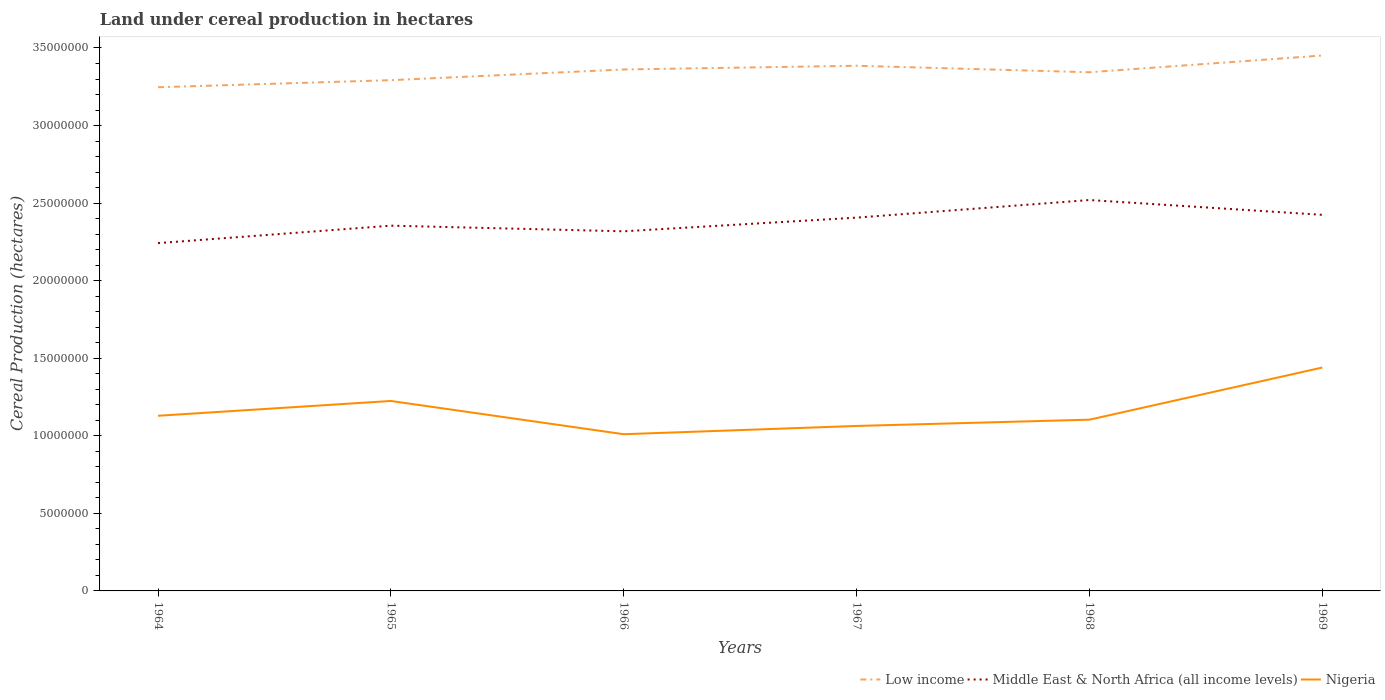Does the line corresponding to Middle East & North Africa (all income levels) intersect with the line corresponding to Low income?
Keep it short and to the point. No. Across all years, what is the maximum land under cereal production in Middle East & North Africa (all income levels)?
Keep it short and to the point. 2.24e+07. In which year was the land under cereal production in Nigeria maximum?
Provide a succinct answer. 1966. What is the total land under cereal production in Middle East & North Africa (all income levels) in the graph?
Your response must be concise. -8.82e+05. What is the difference between the highest and the second highest land under cereal production in Low income?
Your response must be concise. 2.05e+06. Is the land under cereal production in Nigeria strictly greater than the land under cereal production in Middle East & North Africa (all income levels) over the years?
Provide a short and direct response. Yes. Are the values on the major ticks of Y-axis written in scientific E-notation?
Your answer should be very brief. No. Does the graph contain grids?
Make the answer very short. No. Where does the legend appear in the graph?
Offer a very short reply. Bottom right. How many legend labels are there?
Provide a succinct answer. 3. How are the legend labels stacked?
Keep it short and to the point. Horizontal. What is the title of the graph?
Keep it short and to the point. Land under cereal production in hectares. What is the label or title of the Y-axis?
Offer a terse response. Cereal Production (hectares). What is the Cereal Production (hectares) of Low income in 1964?
Provide a short and direct response. 3.25e+07. What is the Cereal Production (hectares) of Middle East & North Africa (all income levels) in 1964?
Give a very brief answer. 2.24e+07. What is the Cereal Production (hectares) in Nigeria in 1964?
Make the answer very short. 1.13e+07. What is the Cereal Production (hectares) in Low income in 1965?
Keep it short and to the point. 3.29e+07. What is the Cereal Production (hectares) in Middle East & North Africa (all income levels) in 1965?
Offer a terse response. 2.35e+07. What is the Cereal Production (hectares) in Nigeria in 1965?
Offer a very short reply. 1.22e+07. What is the Cereal Production (hectares) of Low income in 1966?
Keep it short and to the point. 3.36e+07. What is the Cereal Production (hectares) in Middle East & North Africa (all income levels) in 1966?
Provide a short and direct response. 2.32e+07. What is the Cereal Production (hectares) of Nigeria in 1966?
Your answer should be very brief. 1.01e+07. What is the Cereal Production (hectares) of Low income in 1967?
Your answer should be compact. 3.39e+07. What is the Cereal Production (hectares) in Middle East & North Africa (all income levels) in 1967?
Provide a succinct answer. 2.41e+07. What is the Cereal Production (hectares) in Nigeria in 1967?
Offer a terse response. 1.06e+07. What is the Cereal Production (hectares) in Low income in 1968?
Keep it short and to the point. 3.34e+07. What is the Cereal Production (hectares) in Middle East & North Africa (all income levels) in 1968?
Your answer should be compact. 2.52e+07. What is the Cereal Production (hectares) in Nigeria in 1968?
Offer a very short reply. 1.10e+07. What is the Cereal Production (hectares) of Low income in 1969?
Offer a terse response. 3.45e+07. What is the Cereal Production (hectares) of Middle East & North Africa (all income levels) in 1969?
Provide a succinct answer. 2.42e+07. What is the Cereal Production (hectares) in Nigeria in 1969?
Make the answer very short. 1.44e+07. Across all years, what is the maximum Cereal Production (hectares) of Low income?
Keep it short and to the point. 3.45e+07. Across all years, what is the maximum Cereal Production (hectares) of Middle East & North Africa (all income levels)?
Provide a short and direct response. 2.52e+07. Across all years, what is the maximum Cereal Production (hectares) of Nigeria?
Offer a terse response. 1.44e+07. Across all years, what is the minimum Cereal Production (hectares) in Low income?
Your response must be concise. 3.25e+07. Across all years, what is the minimum Cereal Production (hectares) of Middle East & North Africa (all income levels)?
Provide a short and direct response. 2.24e+07. Across all years, what is the minimum Cereal Production (hectares) in Nigeria?
Your response must be concise. 1.01e+07. What is the total Cereal Production (hectares) in Low income in the graph?
Offer a very short reply. 2.01e+08. What is the total Cereal Production (hectares) of Middle East & North Africa (all income levels) in the graph?
Give a very brief answer. 1.43e+08. What is the total Cereal Production (hectares) in Nigeria in the graph?
Your response must be concise. 6.97e+07. What is the difference between the Cereal Production (hectares) in Low income in 1964 and that in 1965?
Your response must be concise. -4.56e+05. What is the difference between the Cereal Production (hectares) in Middle East & North Africa (all income levels) in 1964 and that in 1965?
Keep it short and to the point. -1.13e+06. What is the difference between the Cereal Production (hectares) of Nigeria in 1964 and that in 1965?
Your response must be concise. -9.54e+05. What is the difference between the Cereal Production (hectares) of Low income in 1964 and that in 1966?
Keep it short and to the point. -1.15e+06. What is the difference between the Cereal Production (hectares) of Middle East & North Africa (all income levels) in 1964 and that in 1966?
Provide a succinct answer. -7.62e+05. What is the difference between the Cereal Production (hectares) in Nigeria in 1964 and that in 1966?
Your response must be concise. 1.19e+06. What is the difference between the Cereal Production (hectares) of Low income in 1964 and that in 1967?
Provide a short and direct response. -1.38e+06. What is the difference between the Cereal Production (hectares) in Middle East & North Africa (all income levels) in 1964 and that in 1967?
Your answer should be very brief. -1.64e+06. What is the difference between the Cereal Production (hectares) in Nigeria in 1964 and that in 1967?
Make the answer very short. 6.56e+05. What is the difference between the Cereal Production (hectares) of Low income in 1964 and that in 1968?
Keep it short and to the point. -9.66e+05. What is the difference between the Cereal Production (hectares) of Middle East & North Africa (all income levels) in 1964 and that in 1968?
Make the answer very short. -2.78e+06. What is the difference between the Cereal Production (hectares) in Nigeria in 1964 and that in 1968?
Your response must be concise. 2.52e+05. What is the difference between the Cereal Production (hectares) of Low income in 1964 and that in 1969?
Your answer should be very brief. -2.05e+06. What is the difference between the Cereal Production (hectares) of Middle East & North Africa (all income levels) in 1964 and that in 1969?
Make the answer very short. -1.82e+06. What is the difference between the Cereal Production (hectares) in Nigeria in 1964 and that in 1969?
Provide a short and direct response. -3.11e+06. What is the difference between the Cereal Production (hectares) of Low income in 1965 and that in 1966?
Your answer should be very brief. -6.89e+05. What is the difference between the Cereal Production (hectares) in Middle East & North Africa (all income levels) in 1965 and that in 1966?
Your answer should be very brief. 3.63e+05. What is the difference between the Cereal Production (hectares) in Nigeria in 1965 and that in 1966?
Your answer should be very brief. 2.14e+06. What is the difference between the Cereal Production (hectares) in Low income in 1965 and that in 1967?
Offer a terse response. -9.29e+05. What is the difference between the Cereal Production (hectares) of Middle East & North Africa (all income levels) in 1965 and that in 1967?
Ensure brevity in your answer.  -5.18e+05. What is the difference between the Cereal Production (hectares) in Nigeria in 1965 and that in 1967?
Ensure brevity in your answer.  1.61e+06. What is the difference between the Cereal Production (hectares) in Low income in 1965 and that in 1968?
Provide a succinct answer. -5.10e+05. What is the difference between the Cereal Production (hectares) of Middle East & North Africa (all income levels) in 1965 and that in 1968?
Provide a succinct answer. -1.65e+06. What is the difference between the Cereal Production (hectares) in Nigeria in 1965 and that in 1968?
Provide a succinct answer. 1.21e+06. What is the difference between the Cereal Production (hectares) of Low income in 1965 and that in 1969?
Offer a terse response. -1.59e+06. What is the difference between the Cereal Production (hectares) of Middle East & North Africa (all income levels) in 1965 and that in 1969?
Offer a very short reply. -6.98e+05. What is the difference between the Cereal Production (hectares) in Nigeria in 1965 and that in 1969?
Your answer should be compact. -2.16e+06. What is the difference between the Cereal Production (hectares) in Low income in 1966 and that in 1967?
Give a very brief answer. -2.39e+05. What is the difference between the Cereal Production (hectares) in Middle East & North Africa (all income levels) in 1966 and that in 1967?
Your answer should be very brief. -8.82e+05. What is the difference between the Cereal Production (hectares) in Nigeria in 1966 and that in 1967?
Give a very brief answer. -5.33e+05. What is the difference between the Cereal Production (hectares) of Low income in 1966 and that in 1968?
Your response must be concise. 1.79e+05. What is the difference between the Cereal Production (hectares) of Middle East & North Africa (all income levels) in 1966 and that in 1968?
Offer a very short reply. -2.02e+06. What is the difference between the Cereal Production (hectares) in Nigeria in 1966 and that in 1968?
Keep it short and to the point. -9.37e+05. What is the difference between the Cereal Production (hectares) in Low income in 1966 and that in 1969?
Offer a very short reply. -9.00e+05. What is the difference between the Cereal Production (hectares) of Middle East & North Africa (all income levels) in 1966 and that in 1969?
Keep it short and to the point. -1.06e+06. What is the difference between the Cereal Production (hectares) in Nigeria in 1966 and that in 1969?
Give a very brief answer. -4.30e+06. What is the difference between the Cereal Production (hectares) of Low income in 1967 and that in 1968?
Make the answer very short. 4.18e+05. What is the difference between the Cereal Production (hectares) in Middle East & North Africa (all income levels) in 1967 and that in 1968?
Your response must be concise. -1.13e+06. What is the difference between the Cereal Production (hectares) of Nigeria in 1967 and that in 1968?
Offer a terse response. -4.04e+05. What is the difference between the Cereal Production (hectares) of Low income in 1967 and that in 1969?
Provide a succinct answer. -6.61e+05. What is the difference between the Cereal Production (hectares) of Middle East & North Africa (all income levels) in 1967 and that in 1969?
Provide a short and direct response. -1.80e+05. What is the difference between the Cereal Production (hectares) of Nigeria in 1967 and that in 1969?
Provide a succinct answer. -3.76e+06. What is the difference between the Cereal Production (hectares) of Low income in 1968 and that in 1969?
Provide a succinct answer. -1.08e+06. What is the difference between the Cereal Production (hectares) of Middle East & North Africa (all income levels) in 1968 and that in 1969?
Your answer should be very brief. 9.55e+05. What is the difference between the Cereal Production (hectares) in Nigeria in 1968 and that in 1969?
Make the answer very short. -3.36e+06. What is the difference between the Cereal Production (hectares) of Low income in 1964 and the Cereal Production (hectares) of Middle East & North Africa (all income levels) in 1965?
Provide a short and direct response. 8.92e+06. What is the difference between the Cereal Production (hectares) in Low income in 1964 and the Cereal Production (hectares) in Nigeria in 1965?
Offer a very short reply. 2.02e+07. What is the difference between the Cereal Production (hectares) of Middle East & North Africa (all income levels) in 1964 and the Cereal Production (hectares) of Nigeria in 1965?
Your answer should be compact. 1.02e+07. What is the difference between the Cereal Production (hectares) of Low income in 1964 and the Cereal Production (hectares) of Middle East & North Africa (all income levels) in 1966?
Make the answer very short. 9.29e+06. What is the difference between the Cereal Production (hectares) in Low income in 1964 and the Cereal Production (hectares) in Nigeria in 1966?
Offer a terse response. 2.24e+07. What is the difference between the Cereal Production (hectares) in Middle East & North Africa (all income levels) in 1964 and the Cereal Production (hectares) in Nigeria in 1966?
Provide a succinct answer. 1.23e+07. What is the difference between the Cereal Production (hectares) in Low income in 1964 and the Cereal Production (hectares) in Middle East & North Africa (all income levels) in 1967?
Your answer should be compact. 8.41e+06. What is the difference between the Cereal Production (hectares) in Low income in 1964 and the Cereal Production (hectares) in Nigeria in 1967?
Ensure brevity in your answer.  2.18e+07. What is the difference between the Cereal Production (hectares) in Middle East & North Africa (all income levels) in 1964 and the Cereal Production (hectares) in Nigeria in 1967?
Offer a very short reply. 1.18e+07. What is the difference between the Cereal Production (hectares) of Low income in 1964 and the Cereal Production (hectares) of Middle East & North Africa (all income levels) in 1968?
Provide a short and direct response. 7.27e+06. What is the difference between the Cereal Production (hectares) of Low income in 1964 and the Cereal Production (hectares) of Nigeria in 1968?
Your answer should be very brief. 2.14e+07. What is the difference between the Cereal Production (hectares) of Middle East & North Africa (all income levels) in 1964 and the Cereal Production (hectares) of Nigeria in 1968?
Your response must be concise. 1.14e+07. What is the difference between the Cereal Production (hectares) in Low income in 1964 and the Cereal Production (hectares) in Middle East & North Africa (all income levels) in 1969?
Make the answer very short. 8.23e+06. What is the difference between the Cereal Production (hectares) in Low income in 1964 and the Cereal Production (hectares) in Nigeria in 1969?
Your answer should be compact. 1.81e+07. What is the difference between the Cereal Production (hectares) in Middle East & North Africa (all income levels) in 1964 and the Cereal Production (hectares) in Nigeria in 1969?
Your answer should be very brief. 8.02e+06. What is the difference between the Cereal Production (hectares) in Low income in 1965 and the Cereal Production (hectares) in Middle East & North Africa (all income levels) in 1966?
Your answer should be compact. 9.74e+06. What is the difference between the Cereal Production (hectares) of Low income in 1965 and the Cereal Production (hectares) of Nigeria in 1966?
Give a very brief answer. 2.28e+07. What is the difference between the Cereal Production (hectares) of Middle East & North Africa (all income levels) in 1965 and the Cereal Production (hectares) of Nigeria in 1966?
Your answer should be very brief. 1.34e+07. What is the difference between the Cereal Production (hectares) in Low income in 1965 and the Cereal Production (hectares) in Middle East & North Africa (all income levels) in 1967?
Your answer should be compact. 8.86e+06. What is the difference between the Cereal Production (hectares) of Low income in 1965 and the Cereal Production (hectares) of Nigeria in 1967?
Your answer should be compact. 2.23e+07. What is the difference between the Cereal Production (hectares) in Middle East & North Africa (all income levels) in 1965 and the Cereal Production (hectares) in Nigeria in 1967?
Make the answer very short. 1.29e+07. What is the difference between the Cereal Production (hectares) in Low income in 1965 and the Cereal Production (hectares) in Middle East & North Africa (all income levels) in 1968?
Your answer should be compact. 7.73e+06. What is the difference between the Cereal Production (hectares) of Low income in 1965 and the Cereal Production (hectares) of Nigeria in 1968?
Your answer should be very brief. 2.19e+07. What is the difference between the Cereal Production (hectares) of Middle East & North Africa (all income levels) in 1965 and the Cereal Production (hectares) of Nigeria in 1968?
Give a very brief answer. 1.25e+07. What is the difference between the Cereal Production (hectares) in Low income in 1965 and the Cereal Production (hectares) in Middle East & North Africa (all income levels) in 1969?
Provide a succinct answer. 8.68e+06. What is the difference between the Cereal Production (hectares) in Low income in 1965 and the Cereal Production (hectares) in Nigeria in 1969?
Provide a short and direct response. 1.85e+07. What is the difference between the Cereal Production (hectares) of Middle East & North Africa (all income levels) in 1965 and the Cereal Production (hectares) of Nigeria in 1969?
Your response must be concise. 9.15e+06. What is the difference between the Cereal Production (hectares) in Low income in 1966 and the Cereal Production (hectares) in Middle East & North Africa (all income levels) in 1967?
Your answer should be compact. 9.55e+06. What is the difference between the Cereal Production (hectares) of Low income in 1966 and the Cereal Production (hectares) of Nigeria in 1967?
Your answer should be very brief. 2.30e+07. What is the difference between the Cereal Production (hectares) in Middle East & North Africa (all income levels) in 1966 and the Cereal Production (hectares) in Nigeria in 1967?
Keep it short and to the point. 1.25e+07. What is the difference between the Cereal Production (hectares) of Low income in 1966 and the Cereal Production (hectares) of Middle East & North Africa (all income levels) in 1968?
Provide a succinct answer. 8.42e+06. What is the difference between the Cereal Production (hectares) of Low income in 1966 and the Cereal Production (hectares) of Nigeria in 1968?
Give a very brief answer. 2.26e+07. What is the difference between the Cereal Production (hectares) of Middle East & North Africa (all income levels) in 1966 and the Cereal Production (hectares) of Nigeria in 1968?
Your answer should be very brief. 1.21e+07. What is the difference between the Cereal Production (hectares) in Low income in 1966 and the Cereal Production (hectares) in Middle East & North Africa (all income levels) in 1969?
Make the answer very short. 9.37e+06. What is the difference between the Cereal Production (hectares) of Low income in 1966 and the Cereal Production (hectares) of Nigeria in 1969?
Ensure brevity in your answer.  1.92e+07. What is the difference between the Cereal Production (hectares) in Middle East & North Africa (all income levels) in 1966 and the Cereal Production (hectares) in Nigeria in 1969?
Make the answer very short. 8.78e+06. What is the difference between the Cereal Production (hectares) of Low income in 1967 and the Cereal Production (hectares) of Middle East & North Africa (all income levels) in 1968?
Make the answer very short. 8.66e+06. What is the difference between the Cereal Production (hectares) of Low income in 1967 and the Cereal Production (hectares) of Nigeria in 1968?
Give a very brief answer. 2.28e+07. What is the difference between the Cereal Production (hectares) in Middle East & North Africa (all income levels) in 1967 and the Cereal Production (hectares) in Nigeria in 1968?
Offer a terse response. 1.30e+07. What is the difference between the Cereal Production (hectares) of Low income in 1967 and the Cereal Production (hectares) of Middle East & North Africa (all income levels) in 1969?
Offer a terse response. 9.61e+06. What is the difference between the Cereal Production (hectares) in Low income in 1967 and the Cereal Production (hectares) in Nigeria in 1969?
Offer a very short reply. 1.95e+07. What is the difference between the Cereal Production (hectares) of Middle East & North Africa (all income levels) in 1967 and the Cereal Production (hectares) of Nigeria in 1969?
Make the answer very short. 9.66e+06. What is the difference between the Cereal Production (hectares) of Low income in 1968 and the Cereal Production (hectares) of Middle East & North Africa (all income levels) in 1969?
Provide a short and direct response. 9.19e+06. What is the difference between the Cereal Production (hectares) in Low income in 1968 and the Cereal Production (hectares) in Nigeria in 1969?
Offer a terse response. 1.90e+07. What is the difference between the Cereal Production (hectares) of Middle East & North Africa (all income levels) in 1968 and the Cereal Production (hectares) of Nigeria in 1969?
Provide a succinct answer. 1.08e+07. What is the average Cereal Production (hectares) in Low income per year?
Your answer should be compact. 3.35e+07. What is the average Cereal Production (hectares) in Middle East & North Africa (all income levels) per year?
Provide a short and direct response. 2.38e+07. What is the average Cereal Production (hectares) in Nigeria per year?
Offer a very short reply. 1.16e+07. In the year 1964, what is the difference between the Cereal Production (hectares) of Low income and Cereal Production (hectares) of Middle East & North Africa (all income levels)?
Your response must be concise. 1.00e+07. In the year 1964, what is the difference between the Cereal Production (hectares) of Low income and Cereal Production (hectares) of Nigeria?
Offer a very short reply. 2.12e+07. In the year 1964, what is the difference between the Cereal Production (hectares) of Middle East & North Africa (all income levels) and Cereal Production (hectares) of Nigeria?
Provide a short and direct response. 1.11e+07. In the year 1965, what is the difference between the Cereal Production (hectares) of Low income and Cereal Production (hectares) of Middle East & North Africa (all income levels)?
Keep it short and to the point. 9.38e+06. In the year 1965, what is the difference between the Cereal Production (hectares) in Low income and Cereal Production (hectares) in Nigeria?
Your answer should be compact. 2.07e+07. In the year 1965, what is the difference between the Cereal Production (hectares) of Middle East & North Africa (all income levels) and Cereal Production (hectares) of Nigeria?
Offer a very short reply. 1.13e+07. In the year 1966, what is the difference between the Cereal Production (hectares) of Low income and Cereal Production (hectares) of Middle East & North Africa (all income levels)?
Your answer should be very brief. 1.04e+07. In the year 1966, what is the difference between the Cereal Production (hectares) of Low income and Cereal Production (hectares) of Nigeria?
Provide a short and direct response. 2.35e+07. In the year 1966, what is the difference between the Cereal Production (hectares) in Middle East & North Africa (all income levels) and Cereal Production (hectares) in Nigeria?
Provide a short and direct response. 1.31e+07. In the year 1967, what is the difference between the Cereal Production (hectares) in Low income and Cereal Production (hectares) in Middle East & North Africa (all income levels)?
Provide a short and direct response. 9.79e+06. In the year 1967, what is the difference between the Cereal Production (hectares) in Low income and Cereal Production (hectares) in Nigeria?
Provide a succinct answer. 2.32e+07. In the year 1967, what is the difference between the Cereal Production (hectares) of Middle East & North Africa (all income levels) and Cereal Production (hectares) of Nigeria?
Your answer should be compact. 1.34e+07. In the year 1968, what is the difference between the Cereal Production (hectares) in Low income and Cereal Production (hectares) in Middle East & North Africa (all income levels)?
Keep it short and to the point. 8.24e+06. In the year 1968, what is the difference between the Cereal Production (hectares) in Low income and Cereal Production (hectares) in Nigeria?
Ensure brevity in your answer.  2.24e+07. In the year 1968, what is the difference between the Cereal Production (hectares) in Middle East & North Africa (all income levels) and Cereal Production (hectares) in Nigeria?
Ensure brevity in your answer.  1.42e+07. In the year 1969, what is the difference between the Cereal Production (hectares) in Low income and Cereal Production (hectares) in Middle East & North Africa (all income levels)?
Offer a very short reply. 1.03e+07. In the year 1969, what is the difference between the Cereal Production (hectares) of Low income and Cereal Production (hectares) of Nigeria?
Make the answer very short. 2.01e+07. In the year 1969, what is the difference between the Cereal Production (hectares) in Middle East & North Africa (all income levels) and Cereal Production (hectares) in Nigeria?
Offer a terse response. 9.84e+06. What is the ratio of the Cereal Production (hectares) of Low income in 1964 to that in 1965?
Ensure brevity in your answer.  0.99. What is the ratio of the Cereal Production (hectares) of Middle East & North Africa (all income levels) in 1964 to that in 1965?
Your answer should be very brief. 0.95. What is the ratio of the Cereal Production (hectares) in Nigeria in 1964 to that in 1965?
Offer a very short reply. 0.92. What is the ratio of the Cereal Production (hectares) in Low income in 1964 to that in 1966?
Give a very brief answer. 0.97. What is the ratio of the Cereal Production (hectares) in Middle East & North Africa (all income levels) in 1964 to that in 1966?
Keep it short and to the point. 0.97. What is the ratio of the Cereal Production (hectares) in Nigeria in 1964 to that in 1966?
Provide a succinct answer. 1.12. What is the ratio of the Cereal Production (hectares) of Low income in 1964 to that in 1967?
Offer a terse response. 0.96. What is the ratio of the Cereal Production (hectares) of Middle East & North Africa (all income levels) in 1964 to that in 1967?
Offer a very short reply. 0.93. What is the ratio of the Cereal Production (hectares) in Nigeria in 1964 to that in 1967?
Provide a short and direct response. 1.06. What is the ratio of the Cereal Production (hectares) of Low income in 1964 to that in 1968?
Your response must be concise. 0.97. What is the ratio of the Cereal Production (hectares) of Middle East & North Africa (all income levels) in 1964 to that in 1968?
Your answer should be compact. 0.89. What is the ratio of the Cereal Production (hectares) of Nigeria in 1964 to that in 1968?
Your answer should be compact. 1.02. What is the ratio of the Cereal Production (hectares) in Low income in 1964 to that in 1969?
Give a very brief answer. 0.94. What is the ratio of the Cereal Production (hectares) of Middle East & North Africa (all income levels) in 1964 to that in 1969?
Keep it short and to the point. 0.92. What is the ratio of the Cereal Production (hectares) in Nigeria in 1964 to that in 1969?
Your answer should be compact. 0.78. What is the ratio of the Cereal Production (hectares) of Low income in 1965 to that in 1966?
Your response must be concise. 0.98. What is the ratio of the Cereal Production (hectares) of Middle East & North Africa (all income levels) in 1965 to that in 1966?
Your answer should be very brief. 1.02. What is the ratio of the Cereal Production (hectares) in Nigeria in 1965 to that in 1966?
Ensure brevity in your answer.  1.21. What is the ratio of the Cereal Production (hectares) of Low income in 1965 to that in 1967?
Provide a short and direct response. 0.97. What is the ratio of the Cereal Production (hectares) in Middle East & North Africa (all income levels) in 1965 to that in 1967?
Offer a very short reply. 0.98. What is the ratio of the Cereal Production (hectares) in Nigeria in 1965 to that in 1967?
Provide a short and direct response. 1.15. What is the ratio of the Cereal Production (hectares) of Low income in 1965 to that in 1968?
Offer a terse response. 0.98. What is the ratio of the Cereal Production (hectares) in Middle East & North Africa (all income levels) in 1965 to that in 1968?
Offer a terse response. 0.93. What is the ratio of the Cereal Production (hectares) in Nigeria in 1965 to that in 1968?
Your answer should be very brief. 1.11. What is the ratio of the Cereal Production (hectares) in Low income in 1965 to that in 1969?
Offer a very short reply. 0.95. What is the ratio of the Cereal Production (hectares) of Middle East & North Africa (all income levels) in 1965 to that in 1969?
Provide a succinct answer. 0.97. What is the ratio of the Cereal Production (hectares) in Nigeria in 1965 to that in 1969?
Keep it short and to the point. 0.85. What is the ratio of the Cereal Production (hectares) in Low income in 1966 to that in 1967?
Provide a short and direct response. 0.99. What is the ratio of the Cereal Production (hectares) in Middle East & North Africa (all income levels) in 1966 to that in 1967?
Make the answer very short. 0.96. What is the ratio of the Cereal Production (hectares) in Nigeria in 1966 to that in 1967?
Your answer should be compact. 0.95. What is the ratio of the Cereal Production (hectares) in Low income in 1966 to that in 1968?
Provide a succinct answer. 1.01. What is the ratio of the Cereal Production (hectares) in Nigeria in 1966 to that in 1968?
Your answer should be very brief. 0.92. What is the ratio of the Cereal Production (hectares) of Low income in 1966 to that in 1969?
Make the answer very short. 0.97. What is the ratio of the Cereal Production (hectares) in Middle East & North Africa (all income levels) in 1966 to that in 1969?
Provide a short and direct response. 0.96. What is the ratio of the Cereal Production (hectares) of Nigeria in 1966 to that in 1969?
Your answer should be very brief. 0.7. What is the ratio of the Cereal Production (hectares) of Low income in 1967 to that in 1968?
Keep it short and to the point. 1.01. What is the ratio of the Cereal Production (hectares) of Middle East & North Africa (all income levels) in 1967 to that in 1968?
Offer a very short reply. 0.95. What is the ratio of the Cereal Production (hectares) in Nigeria in 1967 to that in 1968?
Provide a succinct answer. 0.96. What is the ratio of the Cereal Production (hectares) in Low income in 1967 to that in 1969?
Your answer should be very brief. 0.98. What is the ratio of the Cereal Production (hectares) in Nigeria in 1967 to that in 1969?
Ensure brevity in your answer.  0.74. What is the ratio of the Cereal Production (hectares) of Low income in 1968 to that in 1969?
Make the answer very short. 0.97. What is the ratio of the Cereal Production (hectares) of Middle East & North Africa (all income levels) in 1968 to that in 1969?
Give a very brief answer. 1.04. What is the ratio of the Cereal Production (hectares) in Nigeria in 1968 to that in 1969?
Your response must be concise. 0.77. What is the difference between the highest and the second highest Cereal Production (hectares) of Low income?
Offer a terse response. 6.61e+05. What is the difference between the highest and the second highest Cereal Production (hectares) of Middle East & North Africa (all income levels)?
Your answer should be compact. 9.55e+05. What is the difference between the highest and the second highest Cereal Production (hectares) in Nigeria?
Provide a short and direct response. 2.16e+06. What is the difference between the highest and the lowest Cereal Production (hectares) in Low income?
Give a very brief answer. 2.05e+06. What is the difference between the highest and the lowest Cereal Production (hectares) in Middle East & North Africa (all income levels)?
Ensure brevity in your answer.  2.78e+06. What is the difference between the highest and the lowest Cereal Production (hectares) of Nigeria?
Give a very brief answer. 4.30e+06. 